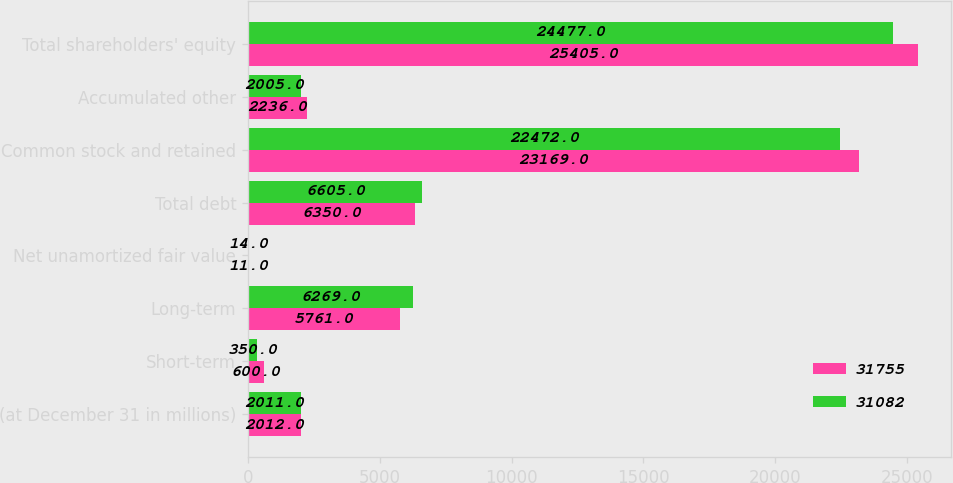Convert chart to OTSL. <chart><loc_0><loc_0><loc_500><loc_500><stacked_bar_chart><ecel><fcel>(at December 31 in millions)<fcel>Short-term<fcel>Long-term<fcel>Net unamortized fair value<fcel>Total debt<fcel>Common stock and retained<fcel>Accumulated other<fcel>Total shareholders' equity<nl><fcel>31755<fcel>2012<fcel>600<fcel>5761<fcel>11<fcel>6350<fcel>23169<fcel>2236<fcel>25405<nl><fcel>31082<fcel>2011<fcel>350<fcel>6269<fcel>14<fcel>6605<fcel>22472<fcel>2005<fcel>24477<nl></chart> 